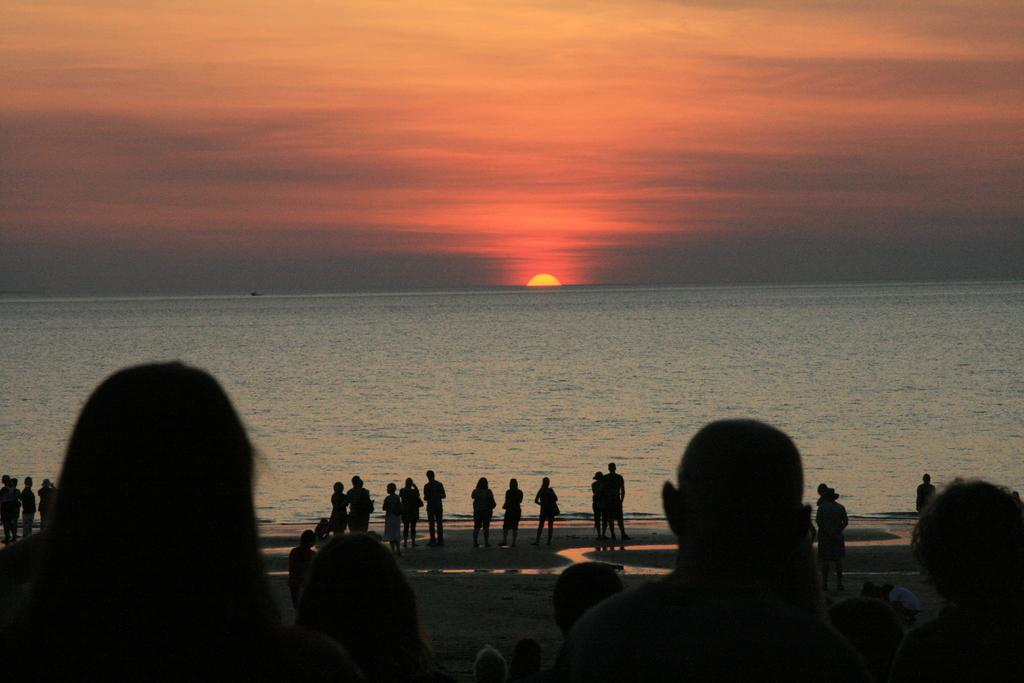What is the overall lighting condition in the image? The image is dark. What type of surface can be seen in the image? There is ground visible in the image. Are there any human figures in the image? Yes, there are people standing in the image. What natural element is present in the image? There is water visible in the image. What can be seen in the background of the image? The sky is visible in the background of the image, and the sun is also visible. How is the parcel being delivered in the image? There is no parcel present in the image, so it cannot be delivered. What stage of development are the people in the image experiencing? There is no information about the people's development in the image. 